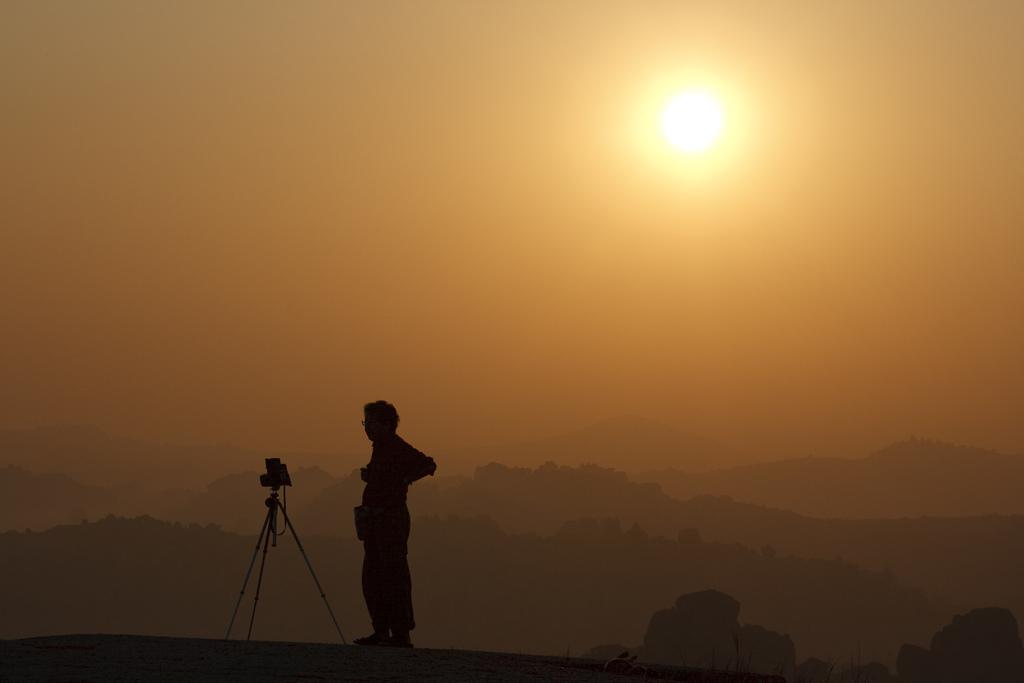What is the main subject of the image? There is a person standing in the image. What can be seen on the left side of the person? There is a camera on a tripod stand on the left side of the person. What type of landscape is visible in the background of the image? Hills are visible in the background of the image. What is the condition of the sky in the background of the image? The sun is visible in the sky in the background of the image. How many trains can be seen passing by in the image? There are no trains visible in the image. What type of brake is used by the person in the image? There is no indication of a brake or any activity involving a brake in the image. 